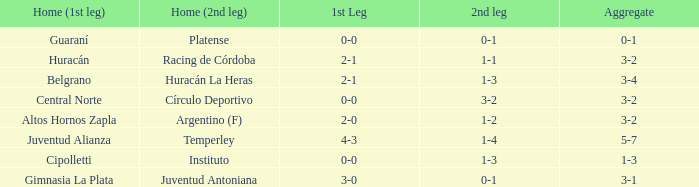Who played at home for the second leg with a score of 0-1 and tied 0-0 in the first leg? Platense. 